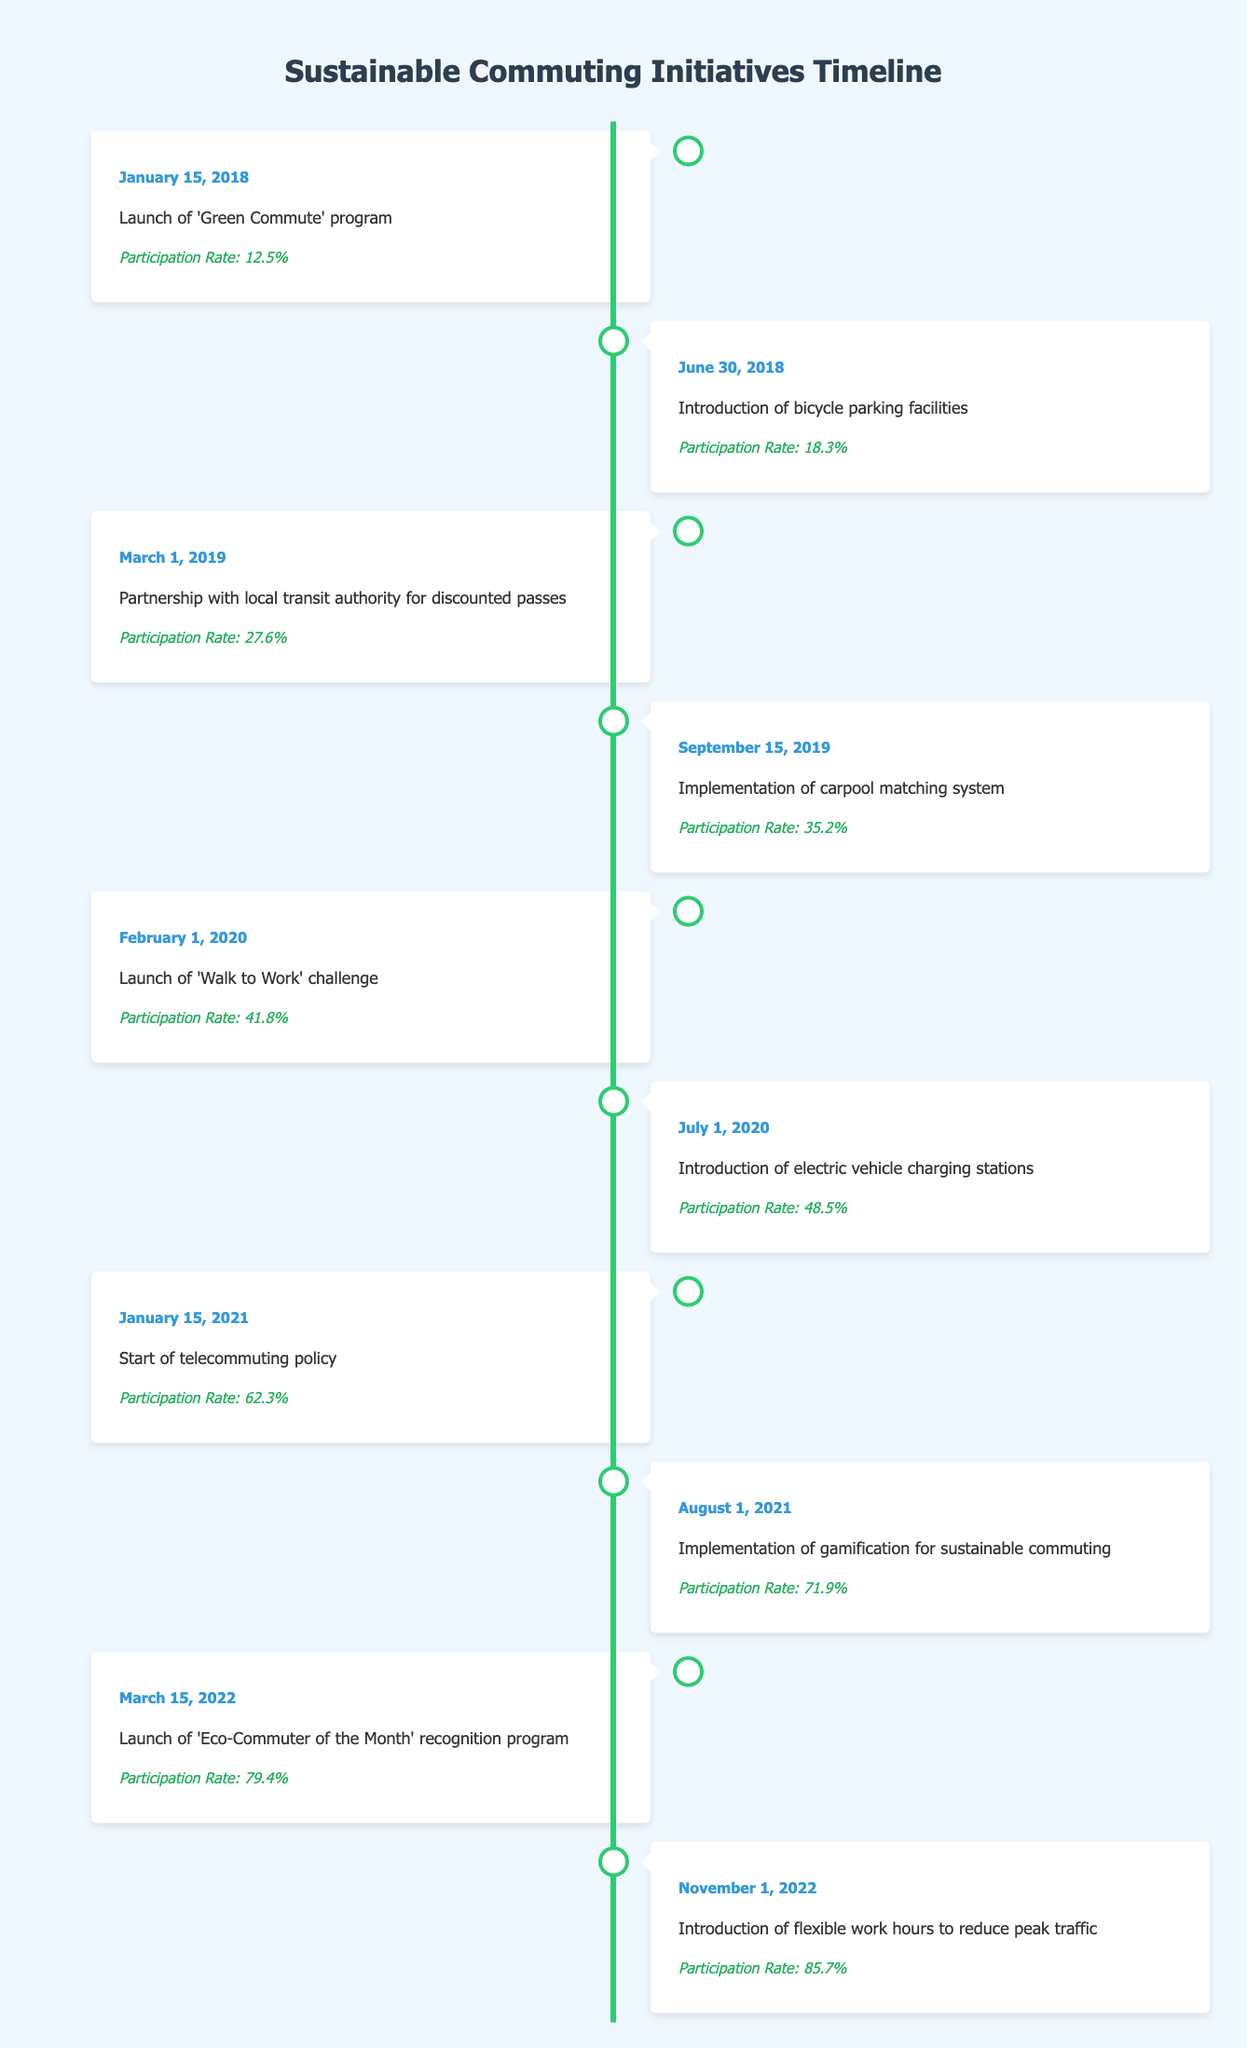What was the participation rate on January 15, 2018? The table shows that on January 15, 2018, the event was the launch of the 'Green Commute' program, with a participation rate of 12.5%.
Answer: 12.5% Which initiative saw a participation rate increase from 41.8% to 48.5%? The participation rate increased from 41.8% to 48.5% between the launch of the 'Walk to Work' challenge on February 1, 2020, and the introduction of electric vehicle charging stations on July 1, 2020.
Answer: Introduction of electric vehicle charging stations Is the participation rate greater than 70% any time in 2021? Yes, the participation rate exceeded 70% in 2021, specifically reaching 71.9% with the implementation of gamification for sustainable commuting on August 1, 2021.
Answer: Yes What was the percentage increase in participation from the start of the 'Green Commute' program to the 'Eco-Commuter of the Month' recognition program? The participation rate increased from 12.5% at the start of the 'Green Commute' program to 79.4% with the 'Eco-Commuter of the Month' program. The increase can be calculated as 79.4% - 12.5% = 66.9%.
Answer: 66.9% Which event had the highest participation rate and what was that rate? The highest participation rate was recorded on November 1, 2022, with the introduction of flexible work hours to reduce peak traffic, which was 85.7%.
Answer: 85.7% 